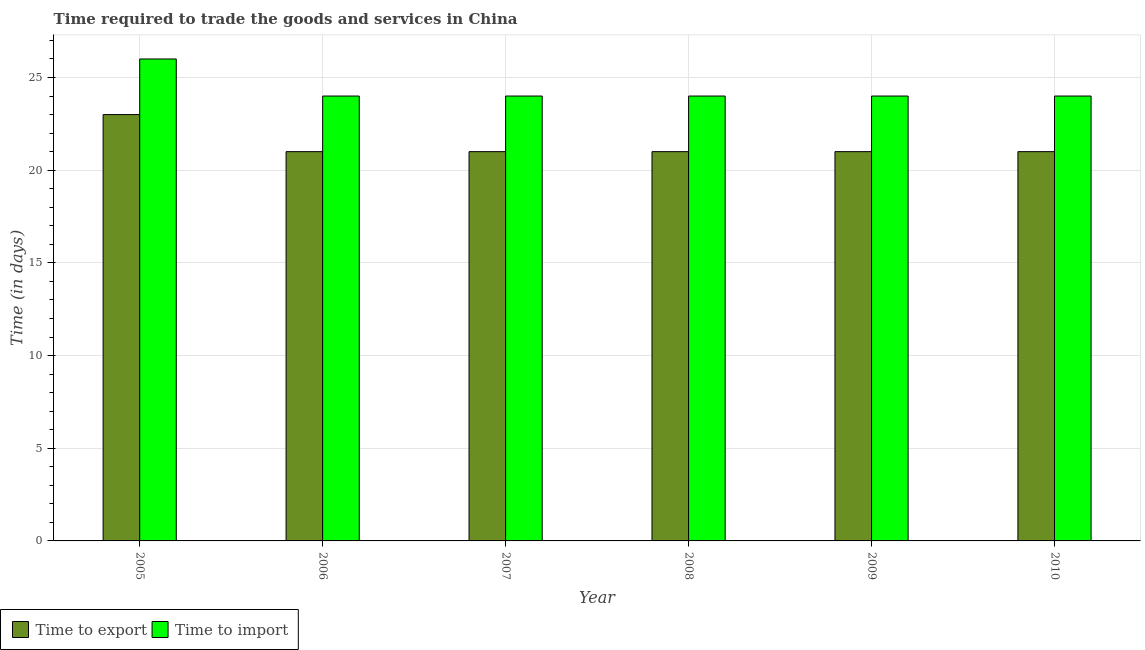How many different coloured bars are there?
Provide a short and direct response. 2. How many groups of bars are there?
Offer a very short reply. 6. Are the number of bars per tick equal to the number of legend labels?
Offer a terse response. Yes. How many bars are there on the 1st tick from the left?
Your answer should be compact. 2. In how many cases, is the number of bars for a given year not equal to the number of legend labels?
Provide a short and direct response. 0. What is the time to export in 2007?
Offer a very short reply. 21. Across all years, what is the maximum time to export?
Ensure brevity in your answer.  23. Across all years, what is the minimum time to import?
Offer a very short reply. 24. In which year was the time to import minimum?
Offer a very short reply. 2006. What is the total time to export in the graph?
Ensure brevity in your answer.  128. What is the difference between the time to import in 2006 and that in 2010?
Make the answer very short. 0. What is the difference between the time to export in 2005 and the time to import in 2007?
Ensure brevity in your answer.  2. What is the average time to export per year?
Make the answer very short. 21.33. In the year 2006, what is the difference between the time to import and time to export?
Keep it short and to the point. 0. In how many years, is the time to export greater than 25 days?
Keep it short and to the point. 0. What is the ratio of the time to export in 2008 to that in 2009?
Your response must be concise. 1. Is the difference between the time to export in 2005 and 2010 greater than the difference between the time to import in 2005 and 2010?
Give a very brief answer. No. What is the difference between the highest and the second highest time to import?
Your answer should be very brief. 2. What is the difference between the highest and the lowest time to import?
Ensure brevity in your answer.  2. What does the 2nd bar from the left in 2006 represents?
Your answer should be very brief. Time to import. What does the 2nd bar from the right in 2006 represents?
Offer a terse response. Time to export. How many bars are there?
Give a very brief answer. 12. How many years are there in the graph?
Your response must be concise. 6. Are the values on the major ticks of Y-axis written in scientific E-notation?
Keep it short and to the point. No. Does the graph contain grids?
Your answer should be compact. Yes. How many legend labels are there?
Keep it short and to the point. 2. What is the title of the graph?
Provide a short and direct response. Time required to trade the goods and services in China. What is the label or title of the Y-axis?
Keep it short and to the point. Time (in days). What is the Time (in days) in Time to import in 2005?
Offer a very short reply. 26. What is the Time (in days) in Time to import in 2006?
Provide a short and direct response. 24. What is the Time (in days) in Time to export in 2007?
Provide a short and direct response. 21. What is the Time (in days) in Time to export in 2008?
Offer a very short reply. 21. What is the Time (in days) in Time to import in 2008?
Give a very brief answer. 24. Across all years, what is the maximum Time (in days) in Time to export?
Keep it short and to the point. 23. What is the total Time (in days) of Time to export in the graph?
Ensure brevity in your answer.  128. What is the total Time (in days) of Time to import in the graph?
Give a very brief answer. 146. What is the difference between the Time (in days) in Time to export in 2005 and that in 2007?
Keep it short and to the point. 2. What is the difference between the Time (in days) in Time to import in 2005 and that in 2007?
Your answer should be very brief. 2. What is the difference between the Time (in days) in Time to import in 2005 and that in 2008?
Give a very brief answer. 2. What is the difference between the Time (in days) of Time to export in 2005 and that in 2009?
Provide a short and direct response. 2. What is the difference between the Time (in days) of Time to export in 2006 and that in 2007?
Offer a very short reply. 0. What is the difference between the Time (in days) in Time to export in 2006 and that in 2008?
Ensure brevity in your answer.  0. What is the difference between the Time (in days) in Time to export in 2006 and that in 2009?
Provide a short and direct response. 0. What is the difference between the Time (in days) of Time to export in 2006 and that in 2010?
Keep it short and to the point. 0. What is the difference between the Time (in days) in Time to import in 2006 and that in 2010?
Provide a succinct answer. 0. What is the difference between the Time (in days) in Time to export in 2007 and that in 2008?
Offer a terse response. 0. What is the difference between the Time (in days) of Time to import in 2007 and that in 2008?
Your answer should be very brief. 0. What is the difference between the Time (in days) in Time to import in 2007 and that in 2009?
Provide a short and direct response. 0. What is the difference between the Time (in days) in Time to export in 2007 and that in 2010?
Provide a succinct answer. 0. What is the difference between the Time (in days) in Time to import in 2007 and that in 2010?
Give a very brief answer. 0. What is the difference between the Time (in days) of Time to import in 2008 and that in 2009?
Keep it short and to the point. 0. What is the difference between the Time (in days) of Time to import in 2009 and that in 2010?
Your answer should be compact. 0. What is the difference between the Time (in days) of Time to export in 2005 and the Time (in days) of Time to import in 2006?
Your answer should be very brief. -1. What is the difference between the Time (in days) of Time to export in 2005 and the Time (in days) of Time to import in 2007?
Give a very brief answer. -1. What is the difference between the Time (in days) of Time to export in 2005 and the Time (in days) of Time to import in 2008?
Your response must be concise. -1. What is the difference between the Time (in days) in Time to export in 2005 and the Time (in days) in Time to import in 2009?
Keep it short and to the point. -1. What is the difference between the Time (in days) in Time to export in 2006 and the Time (in days) in Time to import in 2007?
Give a very brief answer. -3. What is the difference between the Time (in days) in Time to export in 2006 and the Time (in days) in Time to import in 2008?
Your response must be concise. -3. What is the difference between the Time (in days) of Time to export in 2006 and the Time (in days) of Time to import in 2010?
Offer a terse response. -3. What is the difference between the Time (in days) in Time to export in 2007 and the Time (in days) in Time to import in 2010?
Make the answer very short. -3. What is the difference between the Time (in days) in Time to export in 2008 and the Time (in days) in Time to import in 2009?
Offer a terse response. -3. What is the average Time (in days) in Time to export per year?
Offer a terse response. 21.33. What is the average Time (in days) of Time to import per year?
Provide a short and direct response. 24.33. In the year 2007, what is the difference between the Time (in days) of Time to export and Time (in days) of Time to import?
Your answer should be compact. -3. In the year 2008, what is the difference between the Time (in days) of Time to export and Time (in days) of Time to import?
Provide a succinct answer. -3. What is the ratio of the Time (in days) in Time to export in 2005 to that in 2006?
Ensure brevity in your answer.  1.1. What is the ratio of the Time (in days) in Time to export in 2005 to that in 2007?
Ensure brevity in your answer.  1.1. What is the ratio of the Time (in days) of Time to import in 2005 to that in 2007?
Your answer should be compact. 1.08. What is the ratio of the Time (in days) in Time to export in 2005 to that in 2008?
Your response must be concise. 1.1. What is the ratio of the Time (in days) in Time to import in 2005 to that in 2008?
Provide a succinct answer. 1.08. What is the ratio of the Time (in days) in Time to export in 2005 to that in 2009?
Provide a short and direct response. 1.1. What is the ratio of the Time (in days) in Time to export in 2005 to that in 2010?
Your response must be concise. 1.1. What is the ratio of the Time (in days) in Time to import in 2005 to that in 2010?
Keep it short and to the point. 1.08. What is the ratio of the Time (in days) of Time to export in 2006 to that in 2007?
Your response must be concise. 1. What is the ratio of the Time (in days) of Time to export in 2006 to that in 2009?
Keep it short and to the point. 1. What is the ratio of the Time (in days) of Time to export in 2006 to that in 2010?
Make the answer very short. 1. What is the ratio of the Time (in days) of Time to export in 2007 to that in 2010?
Provide a succinct answer. 1. What is the ratio of the Time (in days) in Time to import in 2007 to that in 2010?
Keep it short and to the point. 1. What is the ratio of the Time (in days) in Time to export in 2008 to that in 2009?
Ensure brevity in your answer.  1. What is the ratio of the Time (in days) in Time to import in 2008 to that in 2009?
Your response must be concise. 1. What is the ratio of the Time (in days) of Time to export in 2008 to that in 2010?
Provide a short and direct response. 1. What is the ratio of the Time (in days) of Time to import in 2008 to that in 2010?
Provide a succinct answer. 1. What is the ratio of the Time (in days) of Time to export in 2009 to that in 2010?
Offer a very short reply. 1. What is the difference between the highest and the second highest Time (in days) in Time to export?
Your answer should be very brief. 2. What is the difference between the highest and the second highest Time (in days) of Time to import?
Provide a succinct answer. 2. 